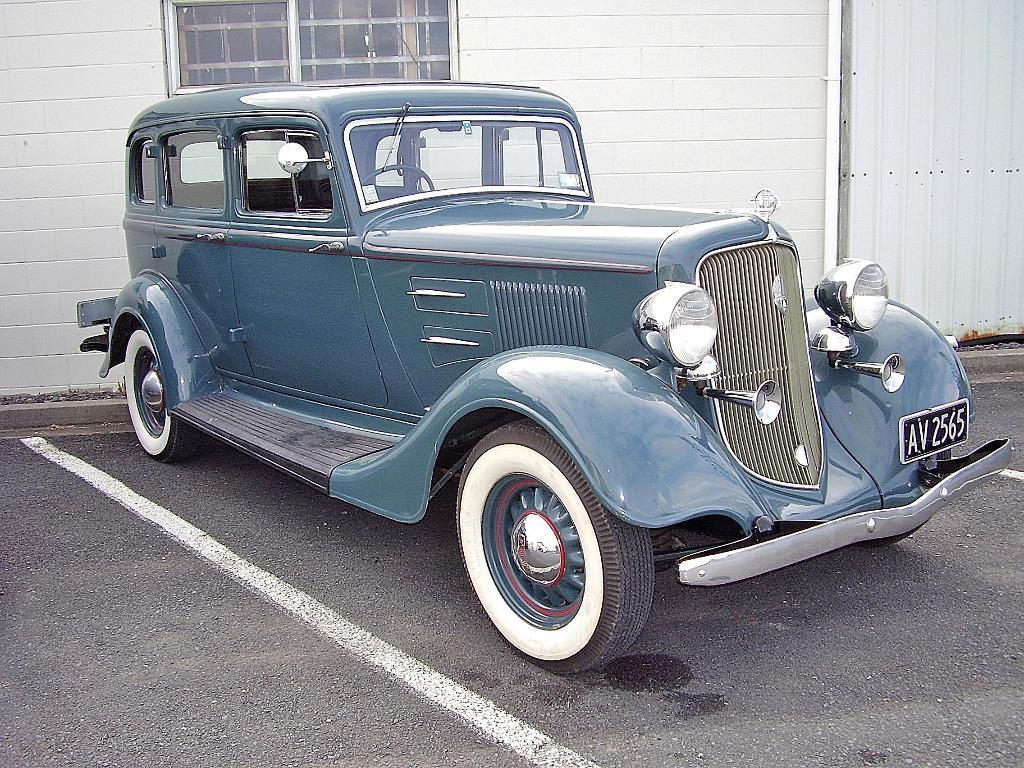What type of vehicle is in the image? There is a blue car in the image. What is behind the car? There is a wall behind the car. Can you describe any other structures or objects in the image? There is a glass window and an iron sheet on the right side of the image. What type of soup is being served in the image? There is no soup present in the image. Can you see any worms crawling on the car in the image? There are no worms visible in the image. 